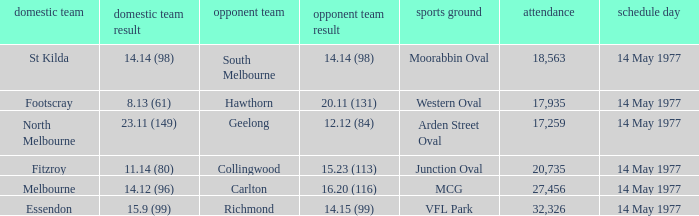How many people were in the crowd with the away team being collingwood? 1.0. 